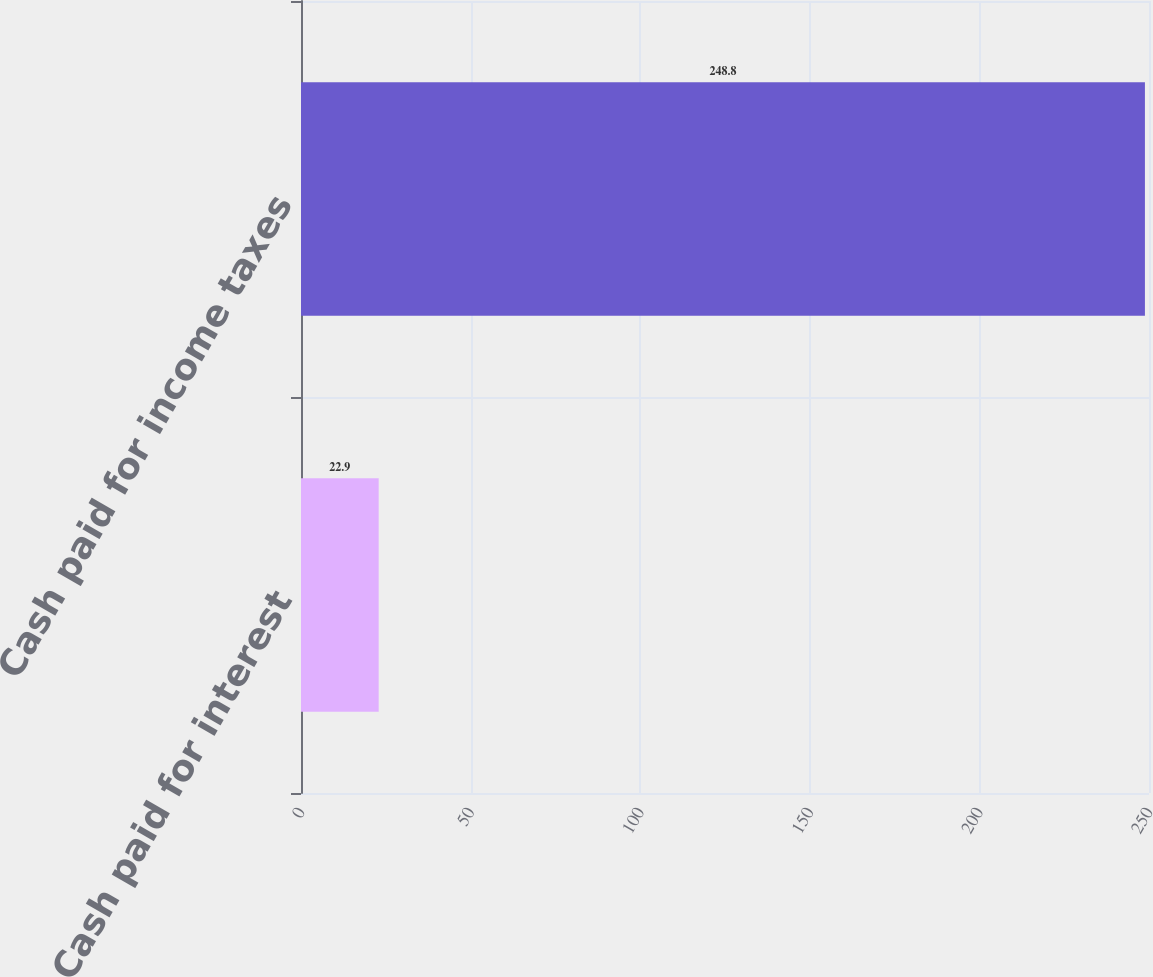<chart> <loc_0><loc_0><loc_500><loc_500><bar_chart><fcel>Cash paid for interest<fcel>Cash paid for income taxes<nl><fcel>22.9<fcel>248.8<nl></chart> 